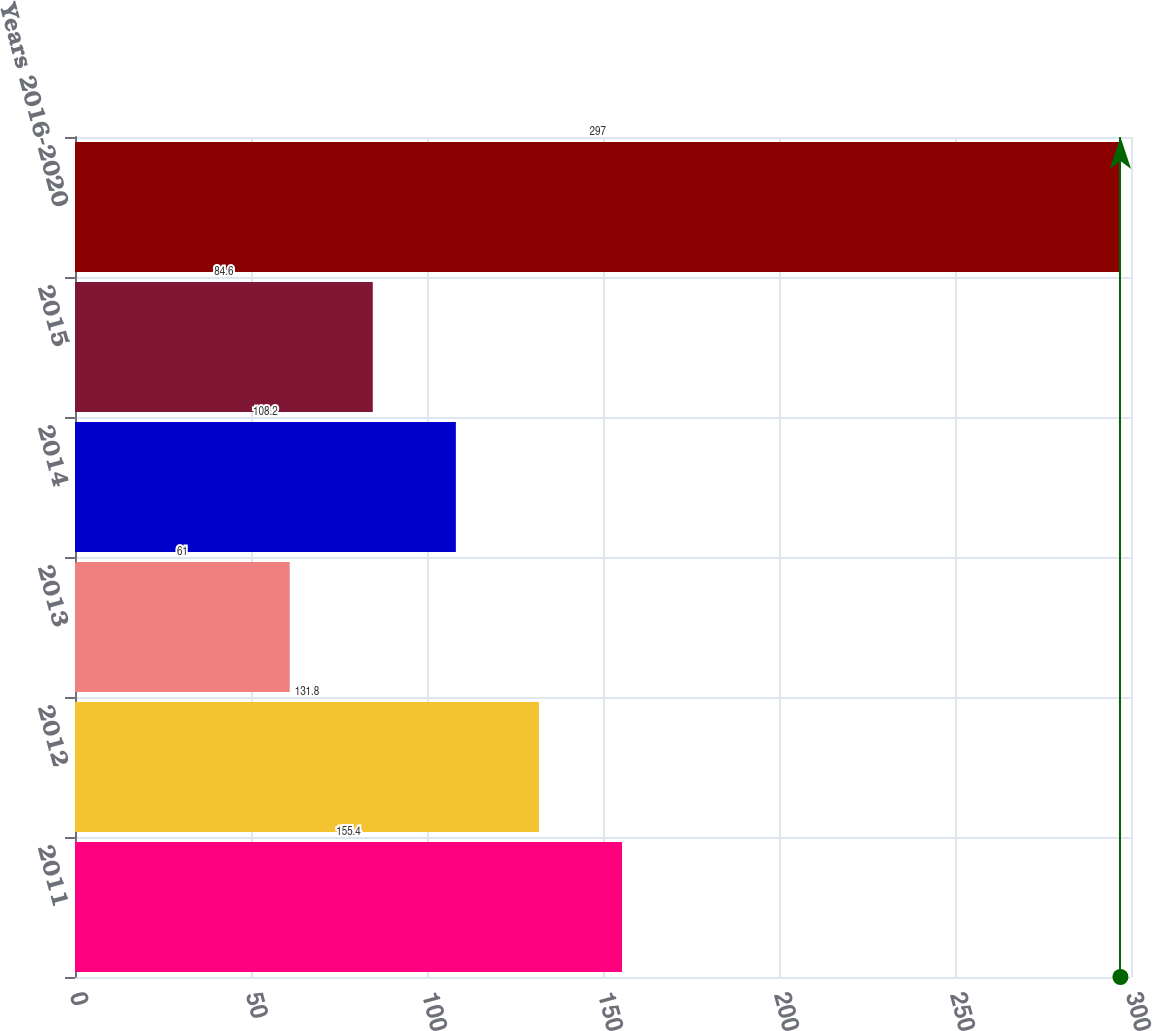Convert chart. <chart><loc_0><loc_0><loc_500><loc_500><bar_chart><fcel>2011<fcel>2012<fcel>2013<fcel>2014<fcel>2015<fcel>Years 2016-2020<nl><fcel>155.4<fcel>131.8<fcel>61<fcel>108.2<fcel>84.6<fcel>297<nl></chart> 